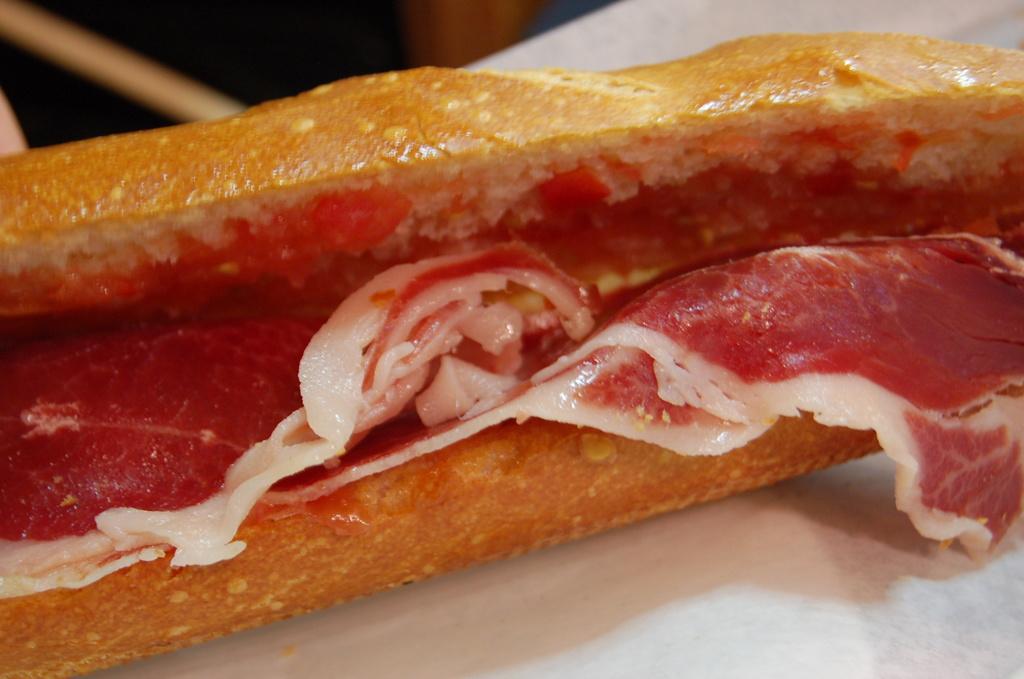How would you summarize this image in a sentence or two? In the image I can see a plate in which there is some food item. 